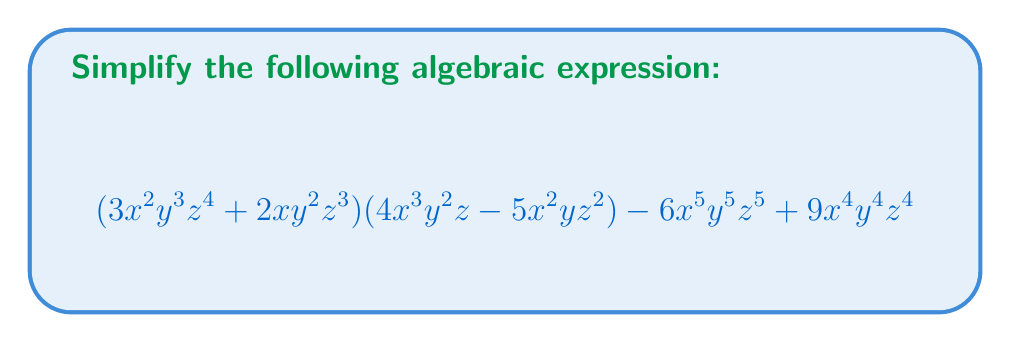Give your solution to this math problem. Let's approach this step-by-step:

1) First, let's distribute the terms in the first parentheses to each term in the second parentheses:

   $(3x^2y^3z^4)(4x^3y^2z) + (3x^2y^3z^4)(-5x^2yz^2) + (2xy^2z^3)(4x^3y^2z) + (2xy^2z^3)(-5x^2yz^2)$

2) Now, let's multiply each of these terms:

   $12x^5y^5z^5 - 15x^4y^4z^6 + 8x^4y^4z^4 - 10x^3y^3z^5$

3) Next, we'll combine this with the remaining terms from the original expression:

   $12x^5y^5z^5 - 15x^4y^4z^6 + 8x^4y^4z^4 - 10x^3y^3z^5 - 6x^5y^5z^5 + 9x^4y^4z^4$

4) Now, we can combine like terms:

   $12x^5y^5z^5 - 6x^5y^5z^5 - 15x^4y^4z^6 + 8x^4y^4z^4 + 9x^4y^4z^4 - 10x^3y^3z^5$

5) Simplifying further:

   $6x^5y^5z^5 - 15x^4y^4z^6 + 17x^4y^4z^4 - 10x^3y^3z^5$

This is the simplest form of the expression, as no further combination of terms is possible.
Answer: $6x^5y^5z^5 - 15x^4y^4z^6 + 17x^4y^4z^4 - 10x^3y^3z^5$ 